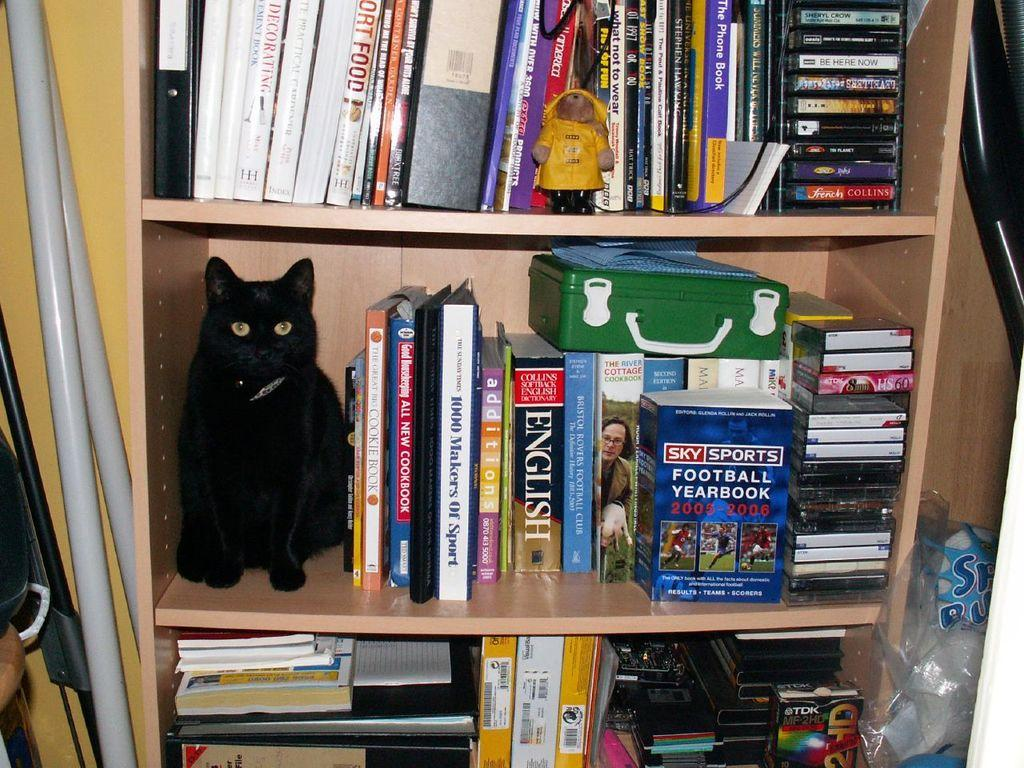What type of furniture is present in the image? A: There is a wooden shelf in the image. What is sitting on the wooden shelf? A black cat is sitting on the shelf. What items can be found on the shelf besides the cat? There are books, a box, a cover, and rods on the shelf. What is visible behind the shelf in the image? There is a wall visible in the image. What statement does the secretary make in the image? There is no secretary present in the image, so no statement can be attributed to them. 